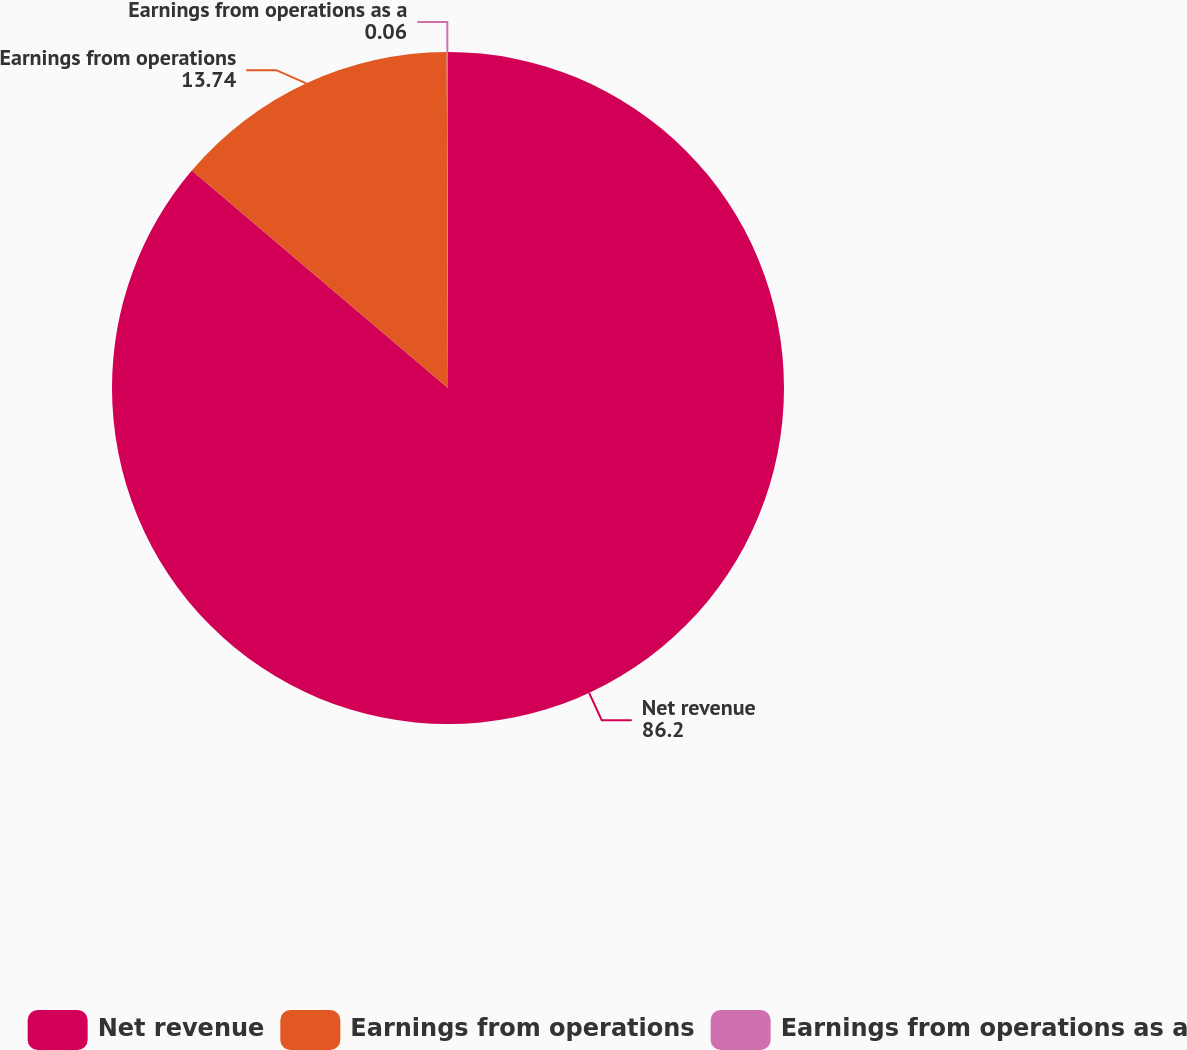<chart> <loc_0><loc_0><loc_500><loc_500><pie_chart><fcel>Net revenue<fcel>Earnings from operations<fcel>Earnings from operations as a<nl><fcel>86.2%<fcel>13.74%<fcel>0.06%<nl></chart> 